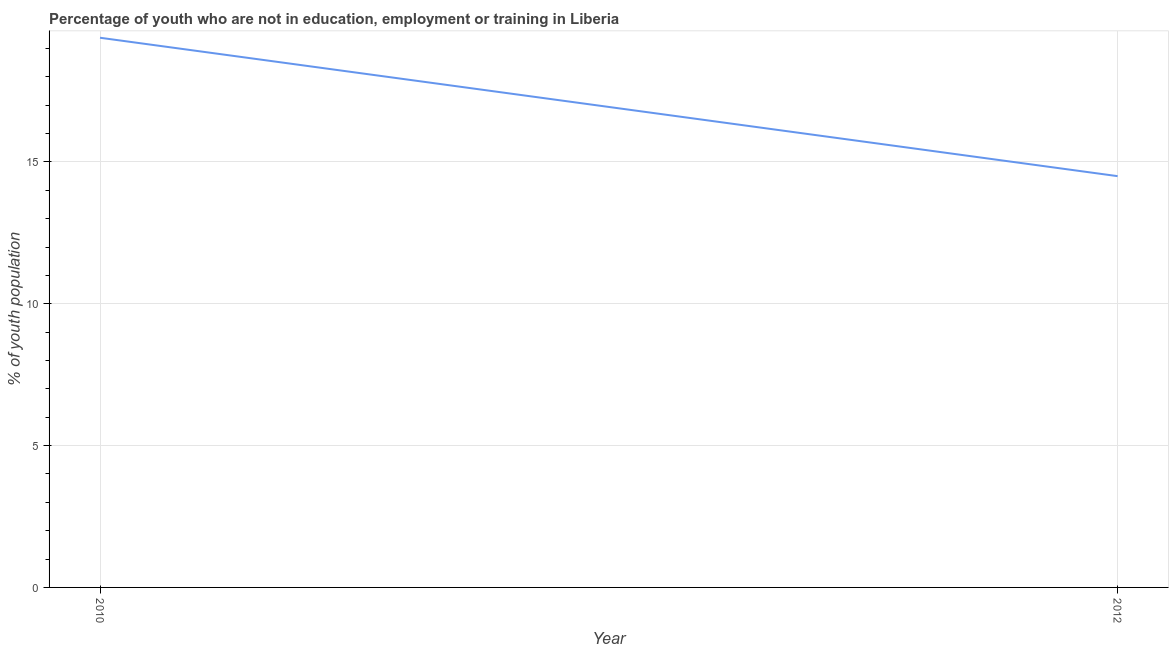What is the unemployed youth population in 2010?
Make the answer very short. 19.38. Across all years, what is the maximum unemployed youth population?
Your response must be concise. 19.38. In which year was the unemployed youth population minimum?
Offer a terse response. 2012. What is the sum of the unemployed youth population?
Keep it short and to the point. 33.88. What is the difference between the unemployed youth population in 2010 and 2012?
Your answer should be compact. 4.88. What is the average unemployed youth population per year?
Make the answer very short. 16.94. What is the median unemployed youth population?
Keep it short and to the point. 16.94. What is the ratio of the unemployed youth population in 2010 to that in 2012?
Your answer should be very brief. 1.34. Is the unemployed youth population in 2010 less than that in 2012?
Keep it short and to the point. No. In how many years, is the unemployed youth population greater than the average unemployed youth population taken over all years?
Provide a short and direct response. 1. How many years are there in the graph?
Offer a terse response. 2. What is the title of the graph?
Your answer should be very brief. Percentage of youth who are not in education, employment or training in Liberia. What is the label or title of the X-axis?
Offer a terse response. Year. What is the label or title of the Y-axis?
Provide a succinct answer. % of youth population. What is the % of youth population of 2010?
Keep it short and to the point. 19.38. What is the % of youth population of 2012?
Provide a succinct answer. 14.5. What is the difference between the % of youth population in 2010 and 2012?
Provide a succinct answer. 4.88. What is the ratio of the % of youth population in 2010 to that in 2012?
Provide a succinct answer. 1.34. 